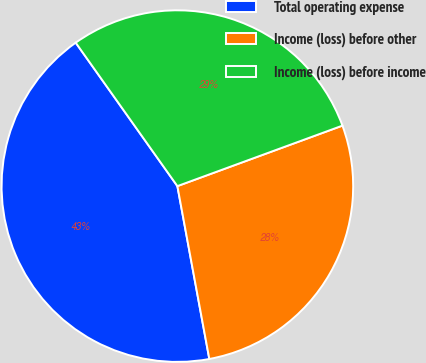Convert chart. <chart><loc_0><loc_0><loc_500><loc_500><pie_chart><fcel>Total operating expense<fcel>Income (loss) before other<fcel>Income (loss) before income<nl><fcel>43.09%<fcel>27.68%<fcel>29.22%<nl></chart> 